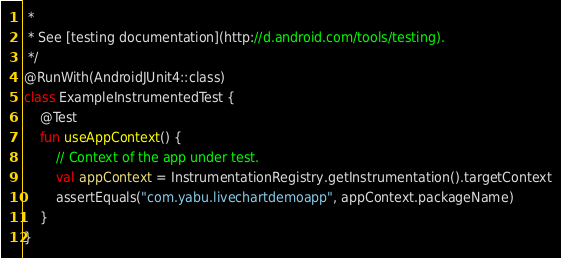Convert code to text. <code><loc_0><loc_0><loc_500><loc_500><_Kotlin_> *
 * See [testing documentation](http://d.android.com/tools/testing).
 */
@RunWith(AndroidJUnit4::class)
class ExampleInstrumentedTest {
    @Test
    fun useAppContext() {
        // Context of the app under test.
        val appContext = InstrumentationRegistry.getInstrumentation().targetContext
        assertEquals("com.yabu.livechartdemoapp", appContext.packageName)
    }
}</code> 